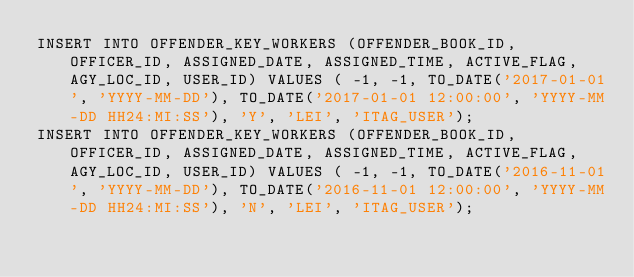Convert code to text. <code><loc_0><loc_0><loc_500><loc_500><_SQL_>INSERT INTO OFFENDER_KEY_WORKERS (OFFENDER_BOOK_ID, OFFICER_ID, ASSIGNED_DATE, ASSIGNED_TIME, ACTIVE_FLAG, AGY_LOC_ID, USER_ID) VALUES ( -1, -1, TO_DATE('2017-01-01', 'YYYY-MM-DD'), TO_DATE('2017-01-01 12:00:00', 'YYYY-MM-DD HH24:MI:SS'), 'Y', 'LEI', 'ITAG_USER');
INSERT INTO OFFENDER_KEY_WORKERS (OFFENDER_BOOK_ID, OFFICER_ID, ASSIGNED_DATE, ASSIGNED_TIME, ACTIVE_FLAG, AGY_LOC_ID, USER_ID) VALUES ( -1, -1, TO_DATE('2016-11-01', 'YYYY-MM-DD'), TO_DATE('2016-11-01 12:00:00', 'YYYY-MM-DD HH24:MI:SS'), 'N', 'LEI', 'ITAG_USER');</code> 